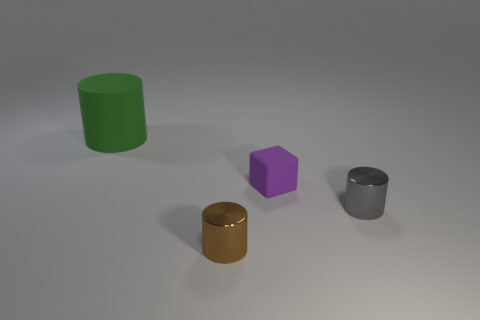Is the thing that is behind the tiny purple matte thing made of the same material as the cylinder on the right side of the brown thing? It appears that the object behind the small purple object is not made of the same material as the cylinder to the right of the brown object. The former seems to have a different texture and sheen, suggesting a different material composition. 